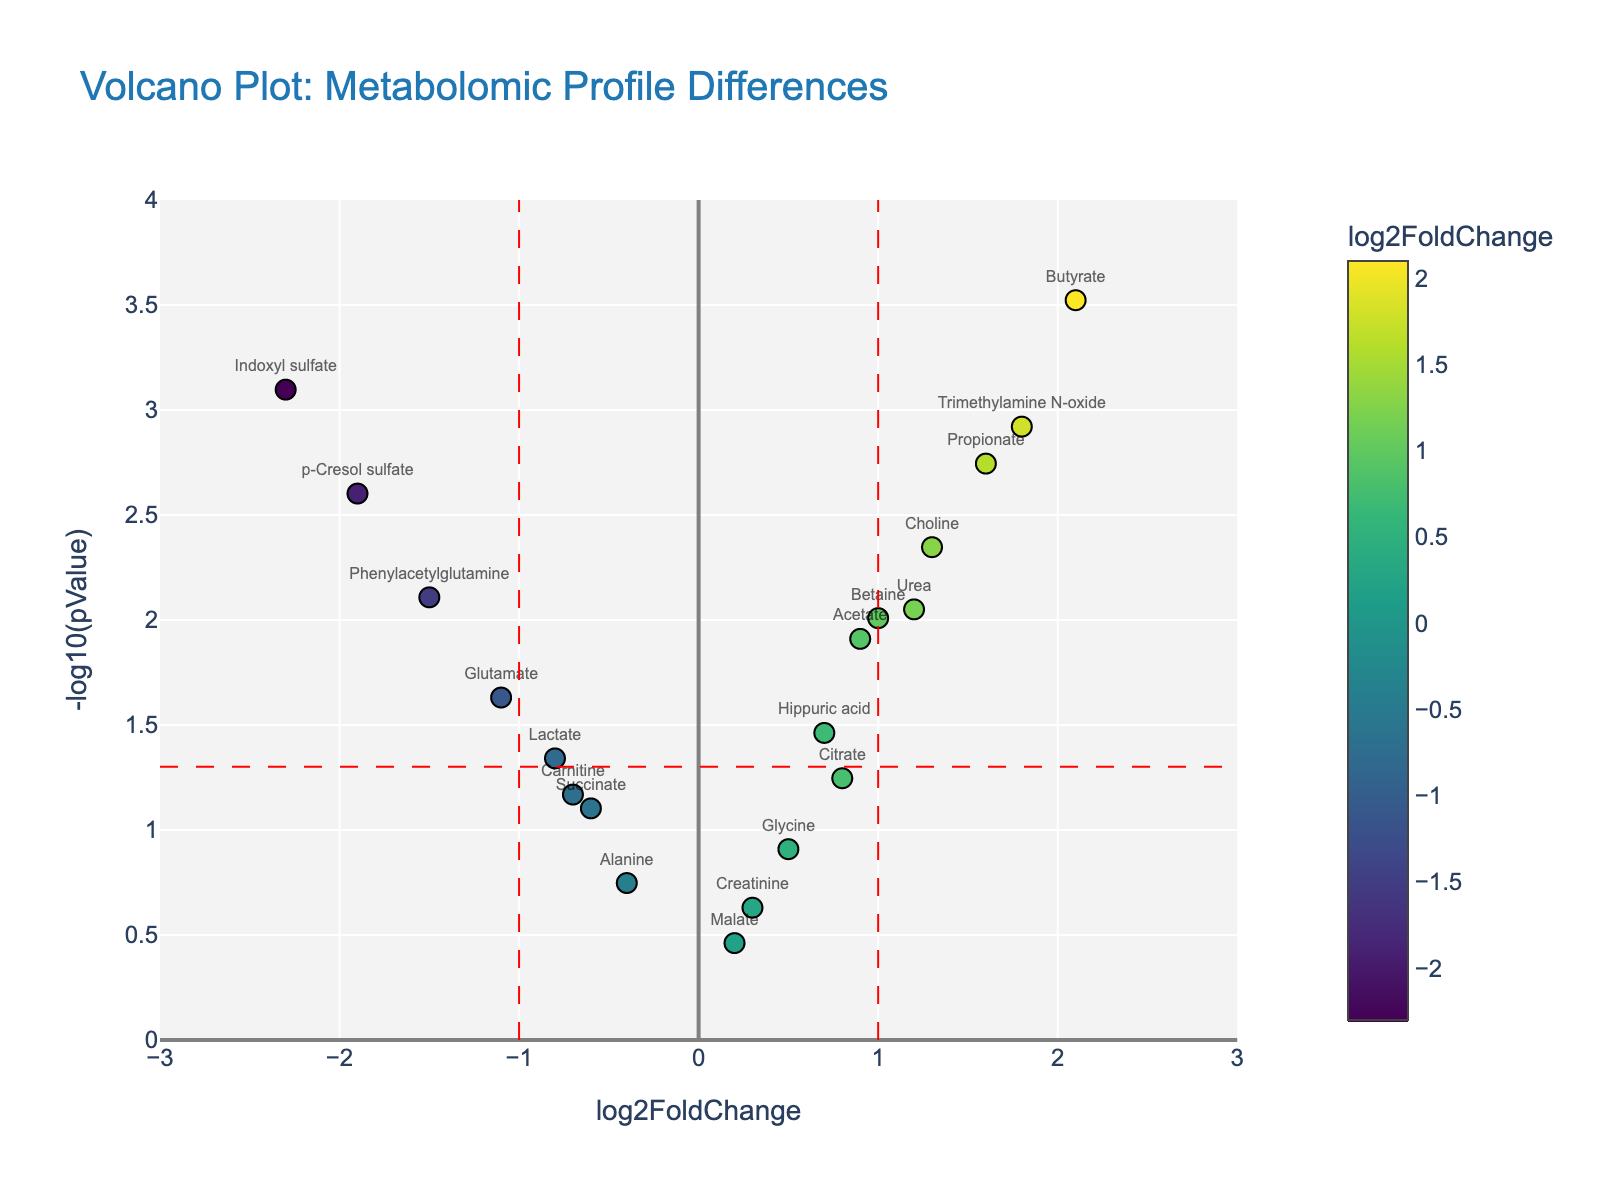Which metabolite has the highest log2FoldChange? Locate the data point furthest to the right on the X-axis, which corresponds to the highest log2FoldChange. The metabolite is "Butyrate."
Answer: Butyrate Which metabolite has the lowest p-value? Identify the data point that is highest on the Y-axis. The corresponding metabolite is "Butyrate."
Answer: Butyrate How many metabolites have a log2FoldChange greater than 1? Count all data points to the right of the vertical line at x=1. The metabolites are "Butyrate," "Trimethylamine N-oxide," "Propionate," "Urea," and "Choline." There are 5 in total.
Answer: 5 What is the log2FoldChange and p-value of "Indoxyl sulfate"? Find "Indoxyl sulfate" on the plot and read its coordinates. The log2FoldChange is -2.3, and the p-value is 0.0008.
Answer: log2FoldChange = -2.3, p-value = 0.0008 Which metabolite has the lowest log2FoldChange? Locate the data point furthest to the left on the X-axis, which corresponds to the lowest log2FoldChange. The metabolite is "Indoxyl sulfate."
Answer: Indoxyl sulfate How many metabolites have a p-value less than 0.05? Count all data points above the horizontal line at y = -log10(0.05). There are 11 metabolites in total.
Answer: 11 Between "Butyrate" and "Lactate", which has a higher log2FoldChange? Compare the X-axis positions of the points labeled "Butyrate" and "Lactate." "Butyrate" is further to the right than "Lactate."
Answer: Butyrate Name two metabolites with similar log2FoldChange but different p-values. Identify data points with similar X-axis positions but different Y-axis positions. "Acetate" and "Hippuric acid" both have log2FoldChange around 0.7-0.9 but differ in p-values.
Answer: Acetate and Hippuric acid Which metabolites are significantly differentially expressed (p-value < 0.05) and have log2FoldChanges less than -1? Look for points that are above the horizontal line at y = -log10(0.05) and to the left of the vertical line at x = -1. These metabolites are "Indoxyl sulfate," "p-Cresol sulfate," and "Phenylacetylglutamine."
Answer: Indoxyl sulfate, p-Cresol sulfate, Phenylacetylglutamine 